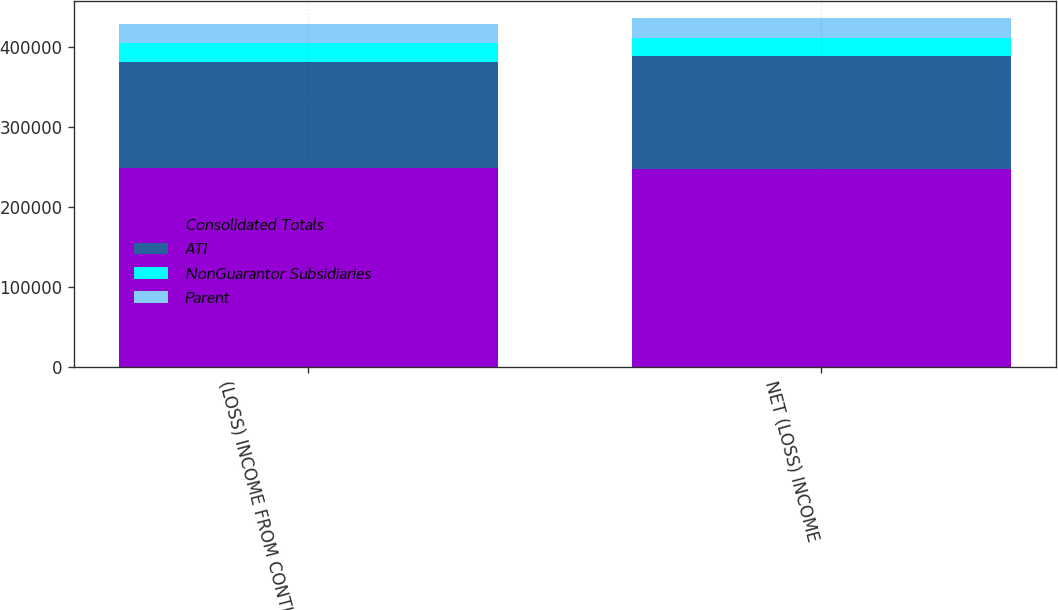<chart> <loc_0><loc_0><loc_500><loc_500><stacked_bar_chart><ecel><fcel>(LOSS) INCOME FROM CONTINUING<fcel>NET (LOSS) INCOME<nl><fcel>Consolidated Totals<fcel>248887<fcel>247587<nl><fcel>ATI<fcel>131861<fcel>140749<nl><fcel>NonGuarantor Subsidiaries<fcel>23499<fcel>22742<nl><fcel>Parent<fcel>24362<fcel>24362<nl></chart> 